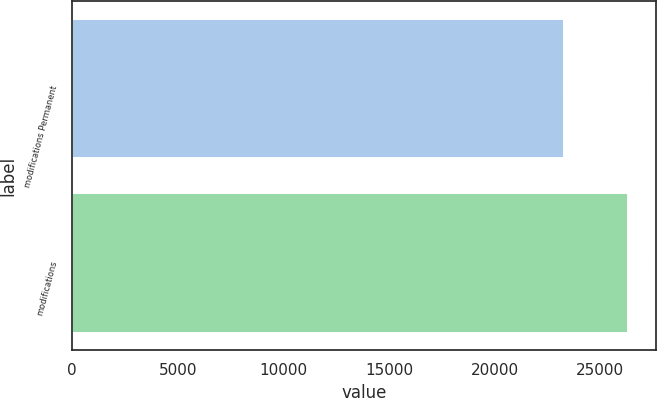<chart> <loc_0><loc_0><loc_500><loc_500><bar_chart><fcel>modifications Permanent<fcel>modifications<nl><fcel>23270<fcel>26303<nl></chart> 